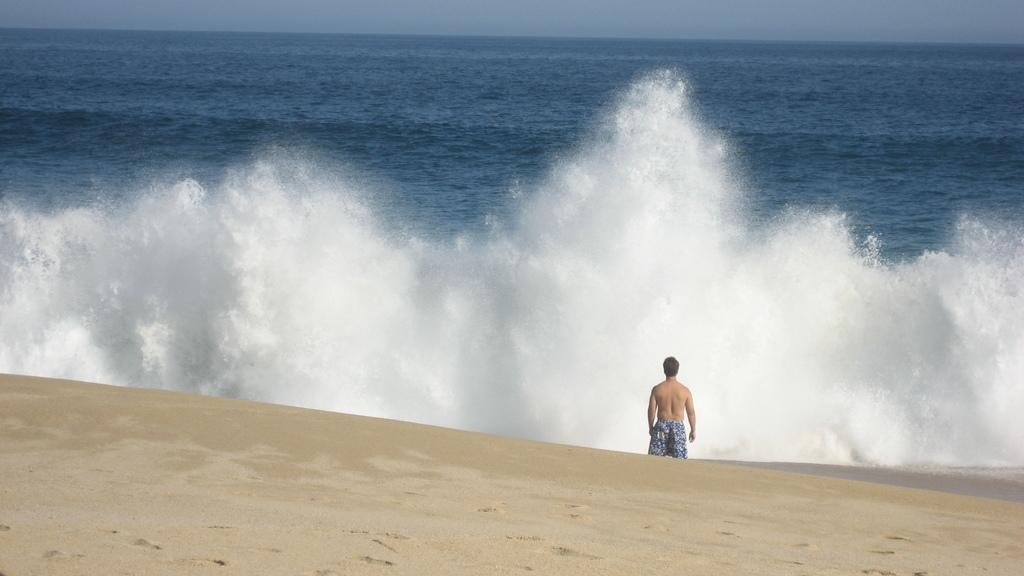What is the location of the image? The image is taken near a beach. Who is visible in the front of the image? There is a man standing in the front of the image. What type of terrain can be seen at the bottom of the image? There is sand at the bottom of the image. What can be seen in the middle of the image? There are waves in the ocean in the middle of the image. What type of skirt is the man wearing in the image? The man is not wearing a skirt in the image; he is dressed in clothing appropriate for a beach setting. What is the man's territory in the image? There is no concept of territory in the image, as it is a photograph of a man standing near a beach. 